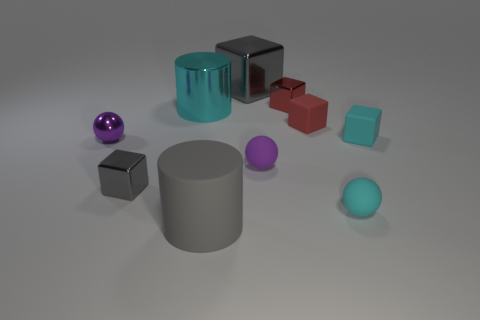Subtract all cyan blocks. How many blocks are left? 4 Subtract all big metallic blocks. How many blocks are left? 4 Subtract all balls. How many objects are left? 7 Subtract all green blocks. Subtract all red cylinders. How many blocks are left? 5 Subtract all small purple rubber cylinders. Subtract all red shiny things. How many objects are left? 9 Add 6 small cyan rubber cubes. How many small cyan rubber cubes are left? 7 Add 1 small cyan matte things. How many small cyan matte things exist? 3 Subtract 0 blue balls. How many objects are left? 10 